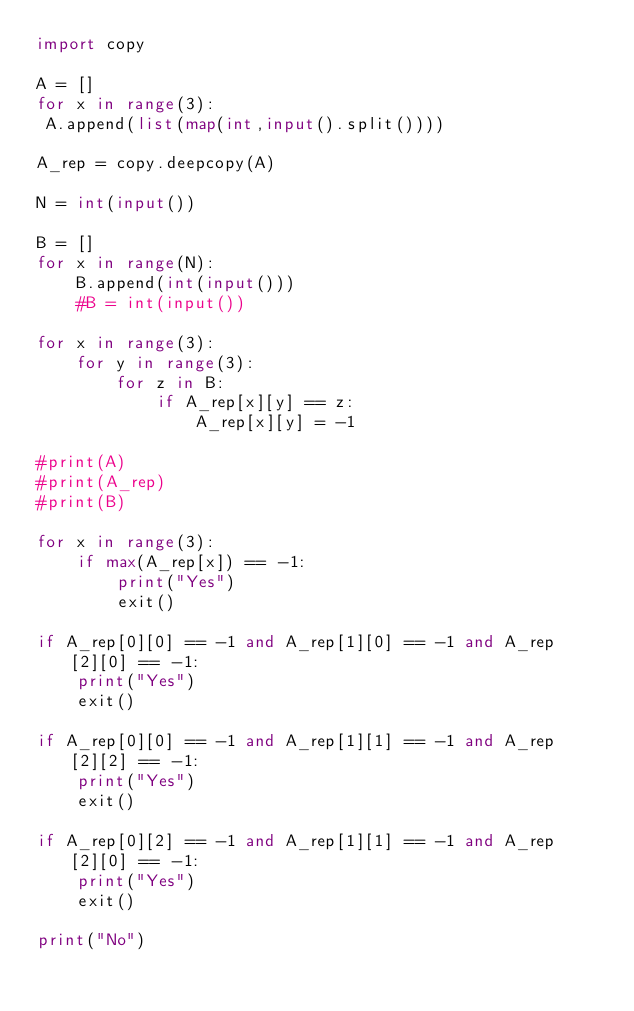Convert code to text. <code><loc_0><loc_0><loc_500><loc_500><_Python_>import copy

A = []
for x in range(3):
 A.append(list(map(int,input().split())))

A_rep = copy.deepcopy(A)

N = int(input())

B = []
for x in range(N):
    B.append(int(input()))
    #B = int(input())

for x in range(3):   
    for y in range(3):
        for z in B:
            if A_rep[x][y] == z:
                A_rep[x][y] = -1

#print(A)
#print(A_rep)
#print(B)

for x in range(3):
    if max(A_rep[x]) == -1:
        print("Yes")
        exit()

if A_rep[0][0] == -1 and A_rep[1][0] == -1 and A_rep[2][0] == -1:
    print("Yes")
    exit()

if A_rep[0][0] == -1 and A_rep[1][1] == -1 and A_rep[2][2] == -1:
    print("Yes")
    exit()

if A_rep[0][2] == -1 and A_rep[1][1] == -1 and A_rep[2][0] == -1:
    print("Yes")
    exit()

print("No")</code> 